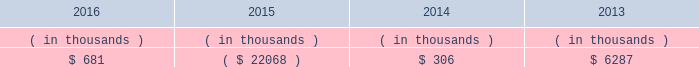Entergy texas , inc .
And subsidiaries management 2019s financial discussion and analysis in addition to the contractual obligations given above , entergy texas expects to contribute approximately $ 17 million to its qualified pension plans and approximately $ 3.2 million to other postretirement health care and life insurance plans in 2017 , although the 2017 required pension contributions will be known with more certainty when the january 1 , 2017 valuations are completed , which is expected by april 1 , 2017 .
See 201ccritical accounting estimates - qualified pension and other postretirement benefits 201d below for a discussion of qualified pension and other postretirement benefits funding .
Also in addition to the contractual obligations , entergy texas has $ 15.6 million of unrecognized tax benefits and interest net of unused tax attributes and payments for which the timing of payments beyond 12 months cannot be reasonably estimated due to uncertainties in the timing of effective settlement of tax positions .
See note 3 to the financial statements for additional information regarding unrecognized tax benefits .
In addition to routine capital spending to maintain operations , the planned capital investment estimate for entergy texas includes specific investments such as the montgomery county power station discussed below ; transmission projects to enhance reliability , reduce congestion , and enable economic growth ; distribution spending to enhance reliability and improve service to customers , including initial investment to support advanced metering ; system improvements ; and other investments .
Estimated capital expenditures are subject to periodic review and modification and may vary based on the ongoing effects of regulatory constraints and requirements , environmental compliance , business opportunities , market volatility , economic trends , business restructuring , changes in project plans , and the ability to access capital .
Management provides more information on long-term debt in note 5 to the financial statements .
As discussed above in 201ccapital structure , 201d entergy texas routinely evaluates its ability to pay dividends to entergy corporation from its earnings .
Sources of capital entergy texas 2019s sources to meet its capital requirements include : 2022 internally generated funds ; 2022 cash on hand ; 2022 debt or preferred stock issuances ; and 2022 bank financing under new or existing facilities .
Entergy texas may refinance , redeem , or otherwise retire debt prior to maturity , to the extent market conditions and interest and dividend rates are favorable .
All debt and common and preferred stock issuances by entergy texas require prior regulatory approval .
Debt issuances are also subject to issuance tests set forth in its bond indenture and other agreements .
Entergy texas has sufficient capacity under these tests to meet its foreseeable capital needs .
Entergy texas 2019s receivables from or ( payables to ) the money pool were as follows as of december 31 for each of the following years. .
See note 4 to the financial statements for a description of the money pool .
Entergy texas has a credit facility in the amount of $ 150 million scheduled to expire in august 2021 .
The credit facility allows entergy texas to issue letters of credit against 50% ( 50 % ) of the borrowing capacity of the facility .
As of december 31 , 2016 , there were no cash borrowings and $ 4.7 million of letters of credit outstanding under the credit facility .
In addition , entergy texas is a party to an uncommitted letter of credit facility as a means to post collateral .
What is the net change in entergy texas 2019s receivables from the money pool from 2014 to 2015? 
Computations: ((22068 * const_m1) - 306)
Answer: -22374.0. 